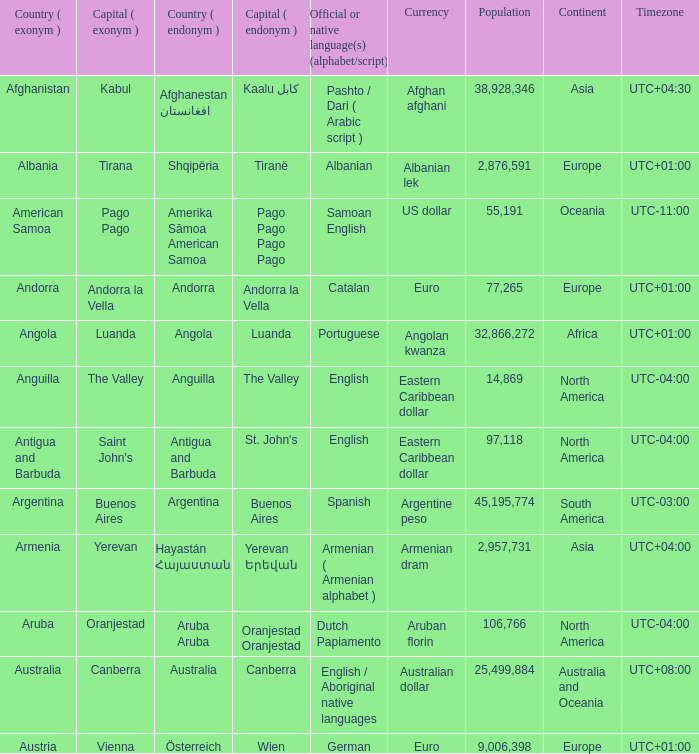What is the local name given to the capital of Anguilla? The Valley. 